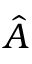Convert formula to latex. <formula><loc_0><loc_0><loc_500><loc_500>\hat { A }</formula> 